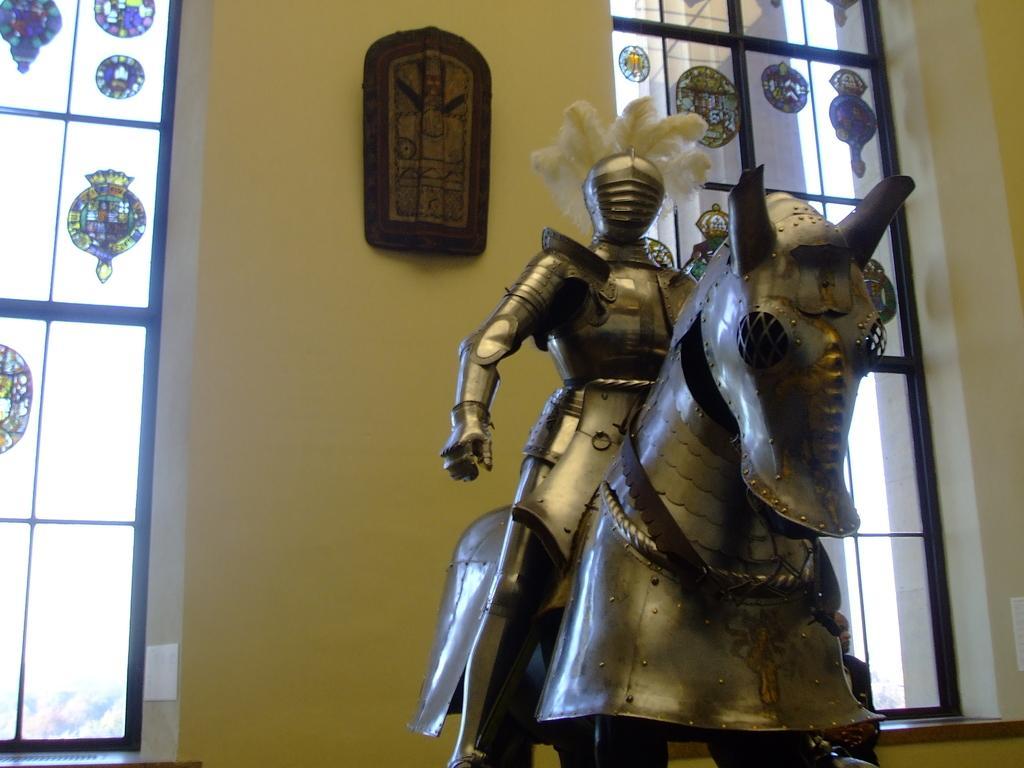Please provide a concise description of this image. In this picture we can see a armor in the background we can find few windows and a wall. 